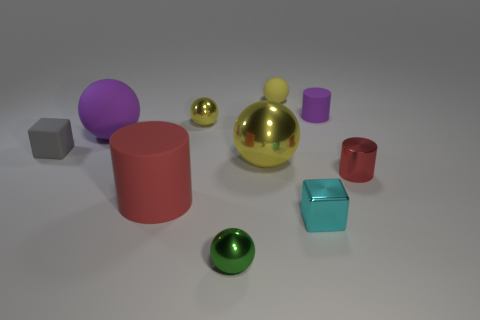How many yellow spheres must be subtracted to get 1 yellow spheres? 2 Subtract all purple blocks. How many yellow balls are left? 3 Subtract all large purple rubber spheres. How many spheres are left? 4 Subtract all red balls. Subtract all gray blocks. How many balls are left? 5 Subtract all cylinders. How many objects are left? 7 Subtract all brown metallic blocks. Subtract all purple objects. How many objects are left? 8 Add 5 tiny gray things. How many tiny gray things are left? 6 Add 2 blue metallic spheres. How many blue metallic spheres exist? 2 Subtract 0 blue cylinders. How many objects are left? 10 